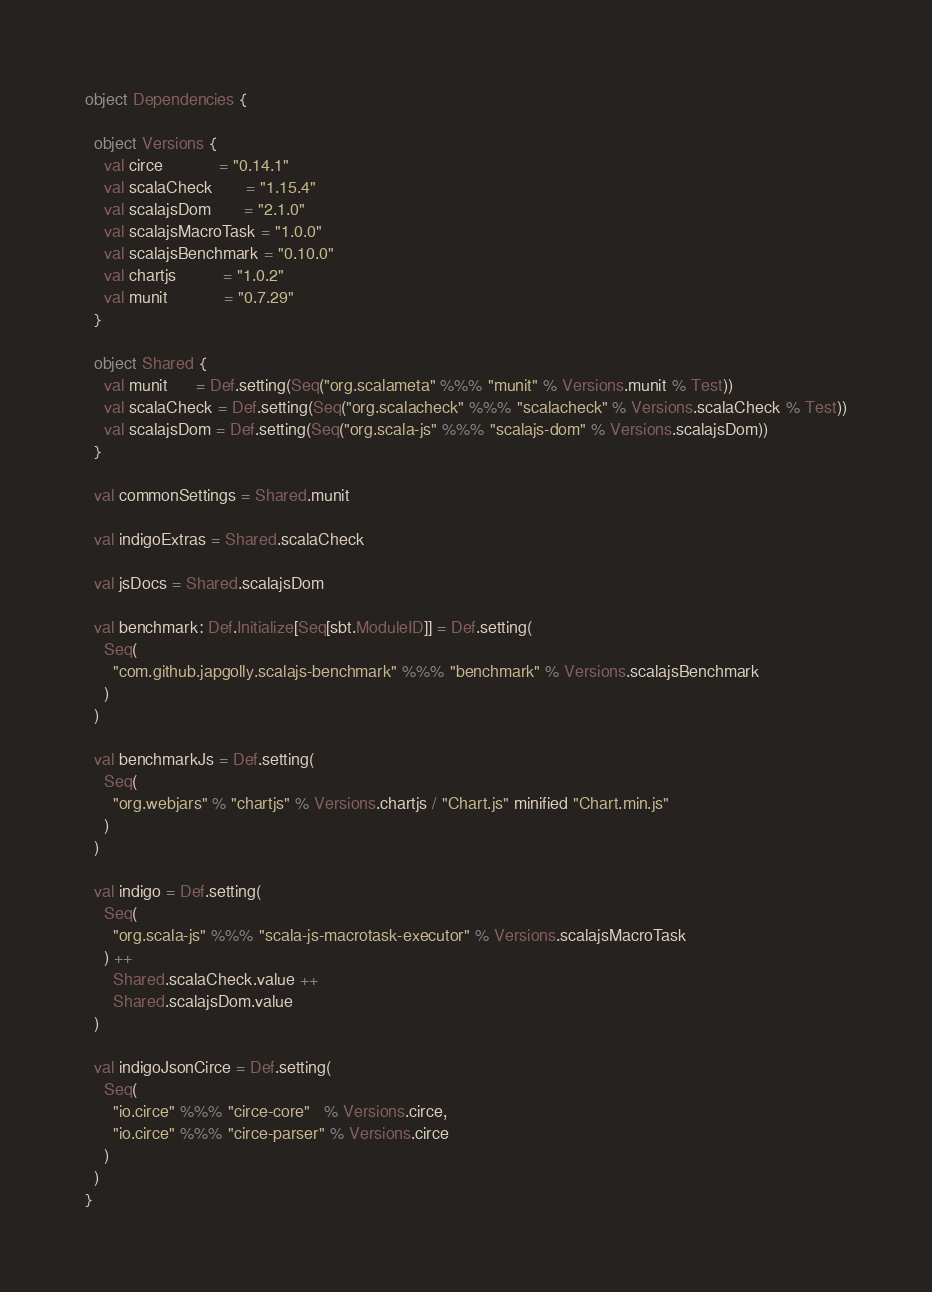<code> <loc_0><loc_0><loc_500><loc_500><_Scala_>
object Dependencies {

  object Versions {
    val circe            = "0.14.1"
    val scalaCheck       = "1.15.4"
    val scalajsDom       = "2.1.0"
    val scalajsMacroTask = "1.0.0"
    val scalajsBenchmark = "0.10.0"
    val chartjs          = "1.0.2"
    val munit            = "0.7.29"
  }

  object Shared {
    val munit      = Def.setting(Seq("org.scalameta" %%% "munit" % Versions.munit % Test))
    val scalaCheck = Def.setting(Seq("org.scalacheck" %%% "scalacheck" % Versions.scalaCheck % Test))
    val scalajsDom = Def.setting(Seq("org.scala-js" %%% "scalajs-dom" % Versions.scalajsDom))
  }

  val commonSettings = Shared.munit

  val indigoExtras = Shared.scalaCheck

  val jsDocs = Shared.scalajsDom

  val benchmark: Def.Initialize[Seq[sbt.ModuleID]] = Def.setting(
    Seq(
      "com.github.japgolly.scalajs-benchmark" %%% "benchmark" % Versions.scalajsBenchmark
    )
  )

  val benchmarkJs = Def.setting(
    Seq(
      "org.webjars" % "chartjs" % Versions.chartjs / "Chart.js" minified "Chart.min.js"
    )
  )

  val indigo = Def.setting(
    Seq(
      "org.scala-js" %%% "scala-js-macrotask-executor" % Versions.scalajsMacroTask
    ) ++
      Shared.scalaCheck.value ++
      Shared.scalajsDom.value
  )

  val indigoJsonCirce = Def.setting(
    Seq(
      "io.circe" %%% "circe-core"   % Versions.circe,
      "io.circe" %%% "circe-parser" % Versions.circe
    )
  )
}
</code> 